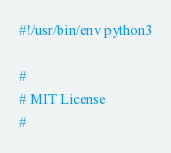Convert code to text. <code><loc_0><loc_0><loc_500><loc_500><_Python_>#!/usr/bin/env python3

#
# MIT License
#</code> 